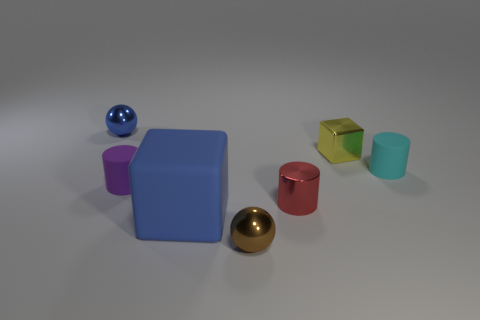Subtract all metallic cylinders. How many cylinders are left? 2 Add 3 small blue spheres. How many objects exist? 10 Subtract 1 cylinders. How many cylinders are left? 2 Subtract all cylinders. How many objects are left? 4 Subtract all cyan cylinders. How many blue cubes are left? 1 Add 1 big yellow metallic things. How many big yellow metallic things exist? 1 Subtract all cyan cylinders. How many cylinders are left? 2 Subtract 0 green blocks. How many objects are left? 7 Subtract all green balls. Subtract all gray cylinders. How many balls are left? 2 Subtract all big brown metallic things. Subtract all cyan matte cylinders. How many objects are left? 6 